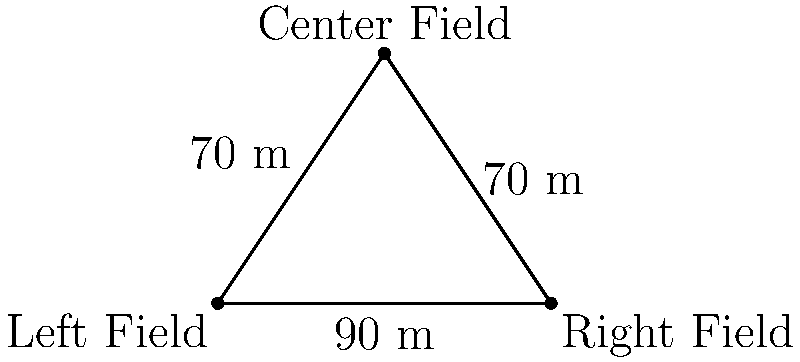As an outfielder, you're discussing defensive positioning with your teammates. The left fielder, center fielder, and right fielder form a triangular region in the outfield. The distance between the left and right fielders is 90 meters, while the distances from the center fielder to both the left and right fielders are 70 meters each. What is the area of the triangular region formed by the three outfielders' positions? To find the area of the triangular region, we can use Heron's formula. Let's approach this step-by-step:

1) First, recall Heron's formula: 
   For a triangle with sides $a$, $b$, and $c$, and semi-perimeter $s = \frac{a+b+c}{2}$,
   the area $A = \sqrt{s(s-a)(s-b)(s-c)}$

2) In our case:
   $a = 90$ m (distance between left and right fielders)
   $b = 70$ m (distance from center to left fielder)
   $c = 70$ m (distance from center to right fielder)

3) Calculate the semi-perimeter $s$:
   $s = \frac{a+b+c}{2} = \frac{90+70+70}{2} = \frac{230}{2} = 115$ m

4) Now, let's substitute these values into Heron's formula:
   $A = \sqrt{115(115-90)(115-70)(115-70)}$

5) Simplify:
   $A = \sqrt{115 \cdot 25 \cdot 45 \cdot 45}$
   $A = \sqrt{2,906,250}$

6) Calculate the square root:
   $A \approx 1,704.77$ square meters

Therefore, the area of the triangular region is approximately 1,704.77 square meters.
Answer: 1,704.77 m² 